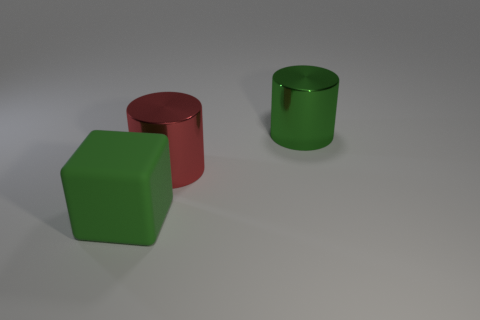What is the color of the big metallic cylinder that is in front of the green object that is on the right side of the green matte object?
Ensure brevity in your answer.  Red. What material is the cylinder that is the same color as the matte object?
Provide a succinct answer. Metal. There is a thing that is behind the red cylinder; what color is it?
Provide a succinct answer. Green. There is a matte object left of the green cylinder; does it have the same size as the red metallic cylinder?
Offer a terse response. Yes. There is a cylinder that is the same color as the rubber cube; what is its size?
Provide a succinct answer. Large. Is there a cylinder of the same size as the green rubber thing?
Provide a succinct answer. Yes. Do the large object that is behind the red metal object and the big thing on the left side of the large red cylinder have the same color?
Give a very brief answer. Yes. Are there any things that have the same color as the matte block?
Your answer should be compact. Yes. How many other objects are the same shape as the red object?
Offer a very short reply. 1. What is the shape of the big green thing that is right of the cube?
Ensure brevity in your answer.  Cylinder. 